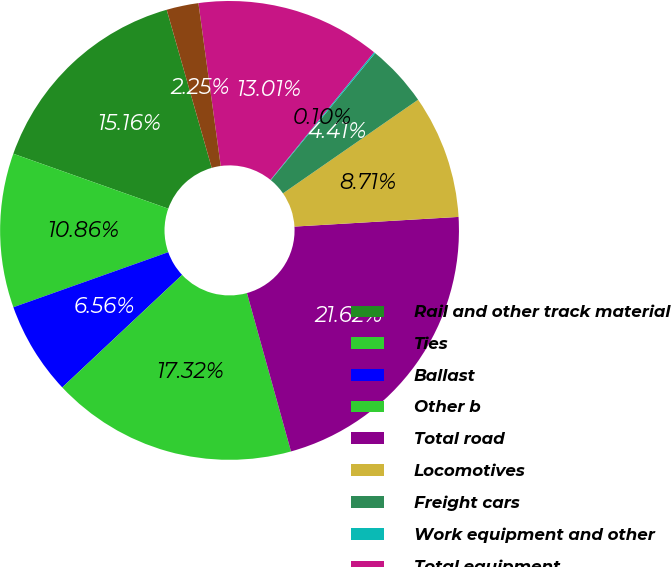Convert chart. <chart><loc_0><loc_0><loc_500><loc_500><pie_chart><fcel>Rail and other track material<fcel>Ties<fcel>Ballast<fcel>Other b<fcel>Total road<fcel>Locomotives<fcel>Freight cars<fcel>Work equipment and other<fcel>Total equipment<fcel>Technology and other<nl><fcel>15.16%<fcel>10.86%<fcel>6.56%<fcel>17.32%<fcel>21.62%<fcel>8.71%<fcel>4.41%<fcel>0.1%<fcel>13.01%<fcel>2.25%<nl></chart> 